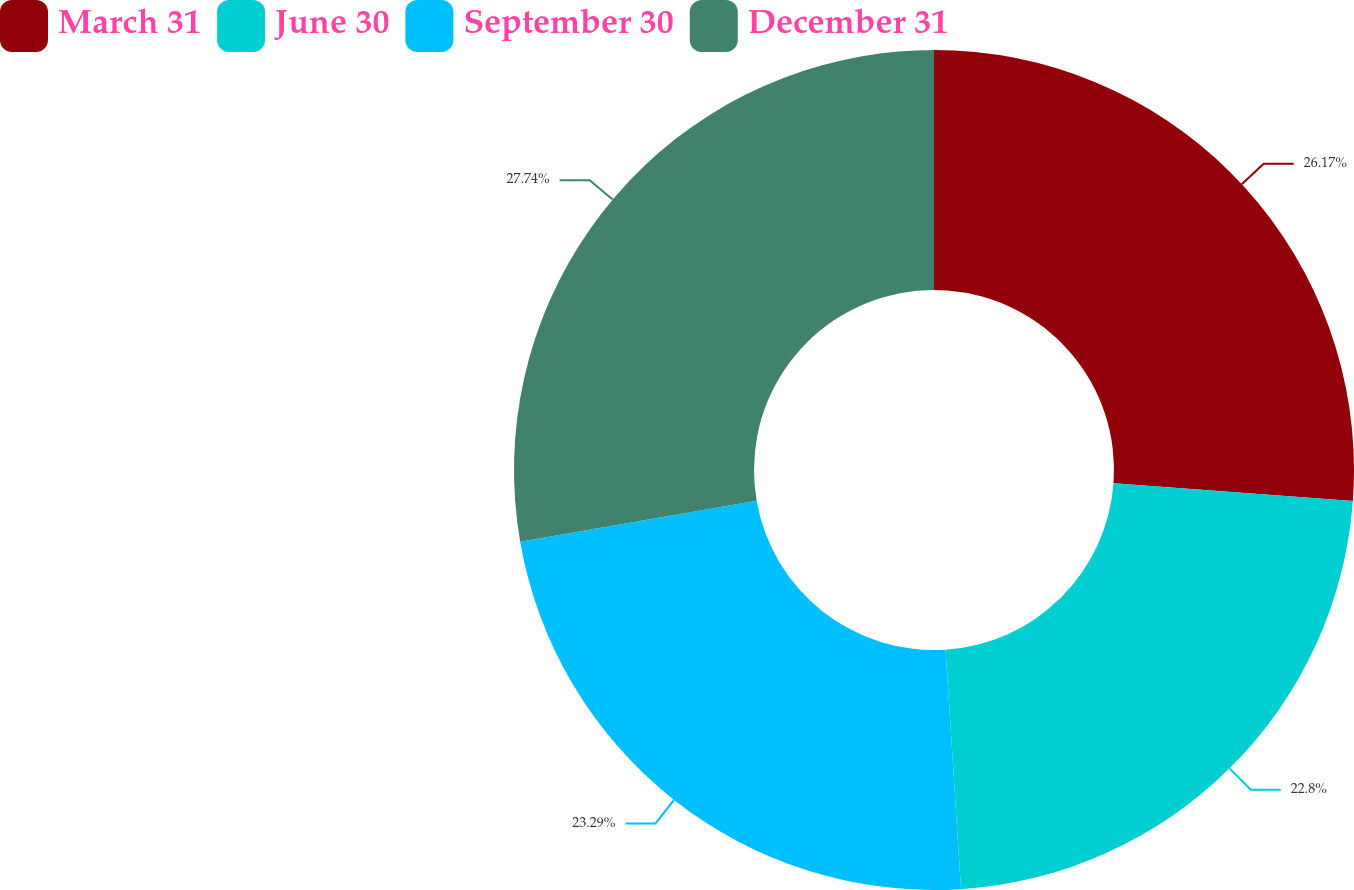Convert chart to OTSL. <chart><loc_0><loc_0><loc_500><loc_500><pie_chart><fcel>March 31<fcel>June 30<fcel>September 30<fcel>December 31<nl><fcel>26.17%<fcel>22.8%<fcel>23.29%<fcel>27.73%<nl></chart> 